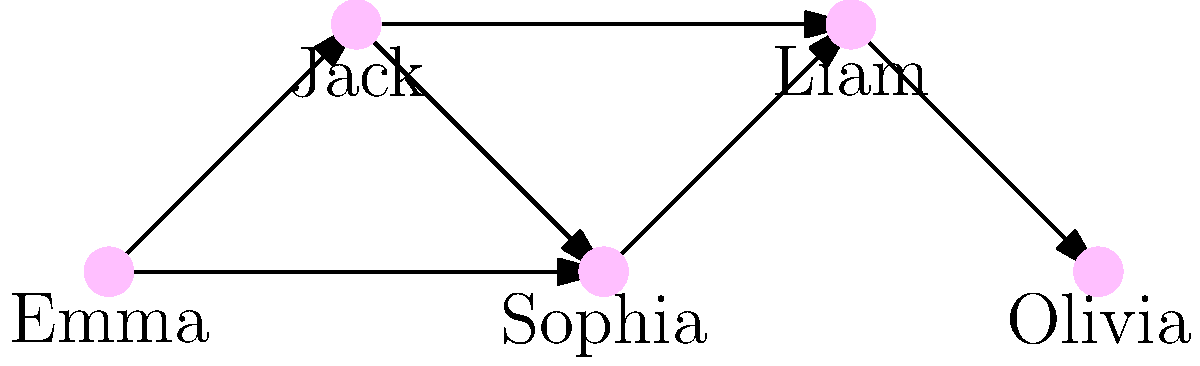In the network diagram representing character relationships in your latest romance novel, which character serves as the primary connector, linking the most characters together and potentially driving the plot forward? To determine the primary connector in this character relationship network, we need to analyze the connections (edges) for each character:

1. Emma: Connected to Jack and Sophia (2 connections)
2. Jack: Connected to Emma, Sophia, and Liam (3 connections)
3. Sophia: Connected to Emma, Jack, and Liam (3 connections)
4. Liam: Connected to Jack, Sophia, and Olivia (3 connections)
5. Olivia: Connected to Liam (1 connection)

From this analysis, we can see that Jack, Sophia, and Liam each have 3 connections, which is the highest number in the network. However, Jack's position in the diagram suggests a more central role, as he connects characters from both ends of the network (Emma and Liam).

In a romance novel, this central character could be:
1. A matchmaker bringing couples together
2. A friend providing advice to multiple characters
3. A character involved in a love triangle or complex romantic situation

Given Jack's central position and high number of connections, he is likely the primary connector in this character network, potentially driving the plot forward by influencing the relationships between other characters.
Answer: Jack 